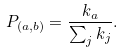<formula> <loc_0><loc_0><loc_500><loc_500>P _ { ( a , b ) } = \frac { k _ { a } } { \sum _ { j } { k _ { j } } } .</formula> 